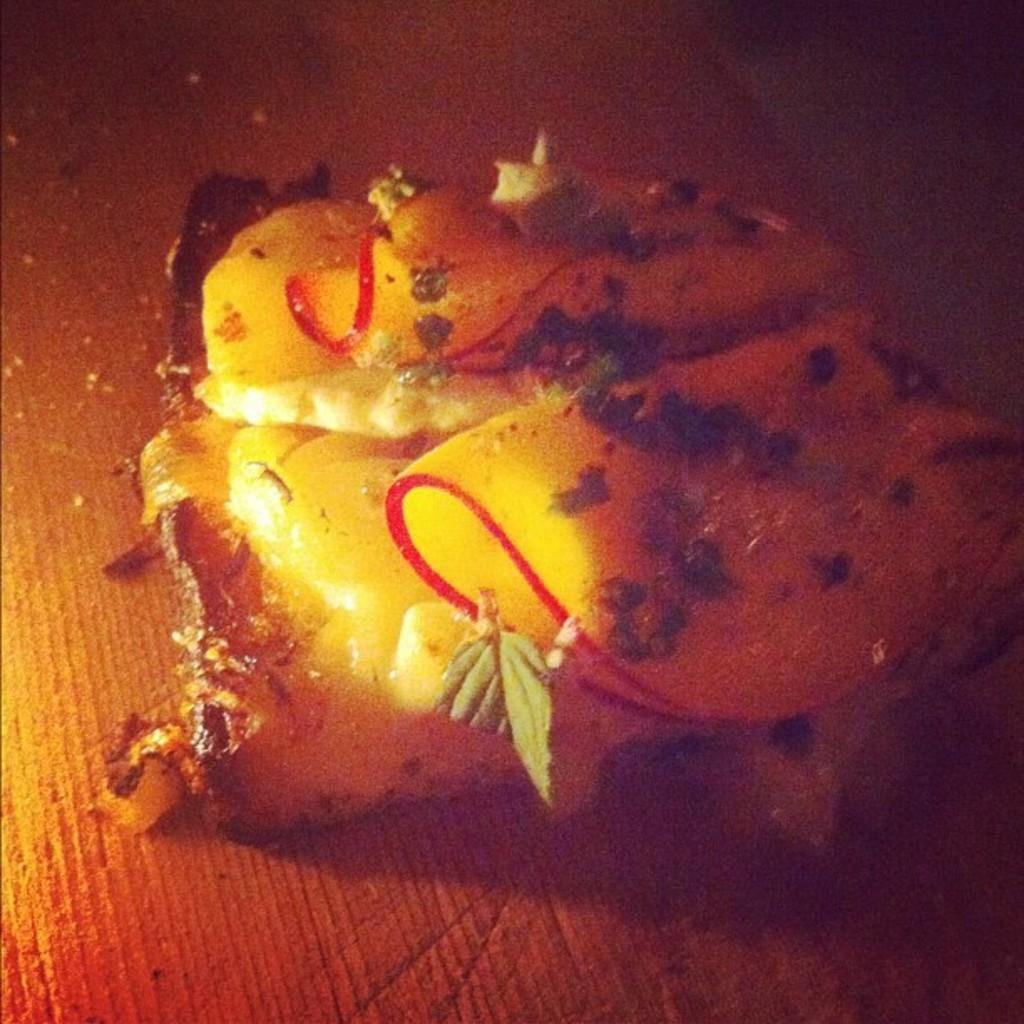What can be seen in the image? There is food in the image. Can you describe the background at the bottom of the image? The background at the bottom of the image is light brown in color. What company is responsible for the fear depicted in the image? There is no fear depicted in the image, nor is there any reference to a company. 